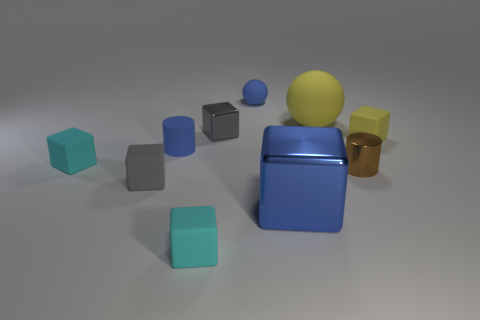How does the lighting in the image affect the atmosphere or mood? The lighting casts soft shadows and generates a calm ambiance. It simulates an evenly lit indoor environment, which helps to highlight the colors and textures of the objects without creating harsh contrasts. 